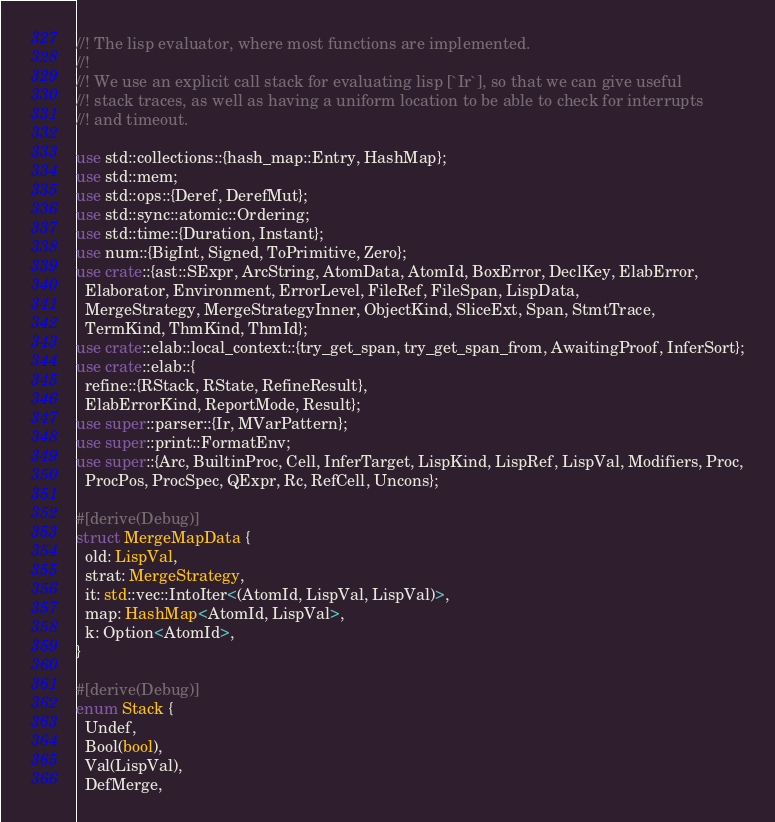<code> <loc_0><loc_0><loc_500><loc_500><_Rust_>//! The lisp evaluator, where most functions are implemented.
//!
//! We use an explicit call stack for evaluating lisp [`Ir`], so that we can give useful
//! stack traces, as well as having a uniform location to be able to check for interrupts
//! and timeout.

use std::collections::{hash_map::Entry, HashMap};
use std::mem;
use std::ops::{Deref, DerefMut};
use std::sync::atomic::Ordering;
use std::time::{Duration, Instant};
use num::{BigInt, Signed, ToPrimitive, Zero};
use crate::{ast::SExpr, ArcString, AtomData, AtomId, BoxError, DeclKey, ElabError,
  Elaborator, Environment, ErrorLevel, FileRef, FileSpan, LispData,
  MergeStrategy, MergeStrategyInner, ObjectKind, SliceExt, Span, StmtTrace,
  TermKind, ThmKind, ThmId};
use crate::elab::local_context::{try_get_span, try_get_span_from, AwaitingProof, InferSort};
use crate::elab::{
  refine::{RStack, RState, RefineResult},
  ElabErrorKind, ReportMode, Result};
use super::parser::{Ir, MVarPattern};
use super::print::FormatEnv;
use super::{Arc, BuiltinProc, Cell, InferTarget, LispKind, LispRef, LispVal, Modifiers, Proc,
  ProcPos, ProcSpec, QExpr, Rc, RefCell, Uncons};

#[derive(Debug)]
struct MergeMapData {
  old: LispVal,
  strat: MergeStrategy,
  it: std::vec::IntoIter<(AtomId, LispVal, LispVal)>,
  map: HashMap<AtomId, LispVal>,
  k: Option<AtomId>,
}

#[derive(Debug)]
enum Stack {
  Undef,
  Bool(bool),
  Val(LispVal),
  DefMerge,</code> 